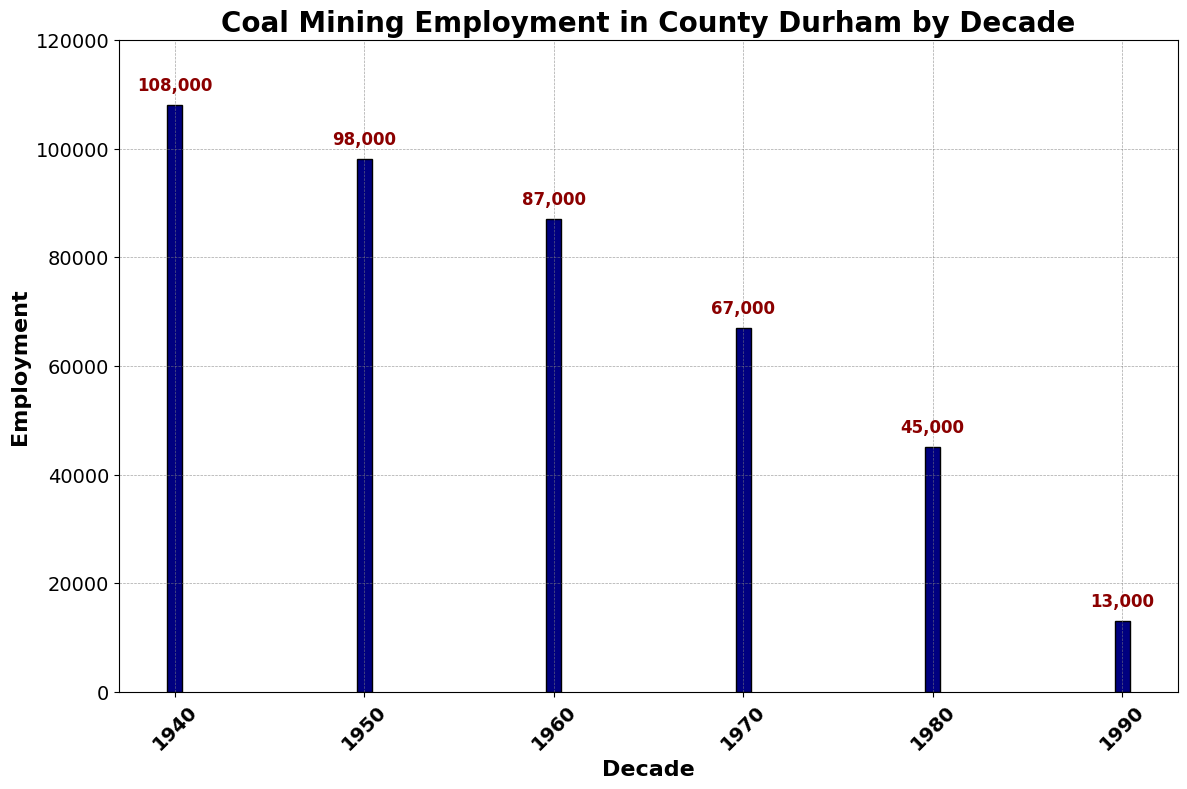What decade had the highest employment in coal mining? The figure shows bar heights representing employment values for each decade. The bar labeled "1940" is the tallest, indicating the highest employment.
Answer: 1940 Compare the employment between the 1960s and 1990s. Which decade had higher employment? The height of the bar for the 1960s is significantly taller than the bar for the 1990s, indicating higher employment in the 1960s.
Answer: 1960s What is the employment difference between the 1950s and 1980s? The bar for the 1950s shows 98,000 and the bar for the 1980s shows 45,000. The difference is 98,000 - 45,000.
Answer: 53,000 Which decade saw the greatest decline in coal mining employment compared to the previous decade? By comparing the heights of consecutive bars, the sharpest decline is between the 1980s (45,000) and the 1990s (13,000).
Answer: 1980s to 1990s What was the total employment in coal mining across all decades shown? Summing the values atop each bar: 108,000 + 98,000 + 87,000 + 67,000 + 45,000 + 13,000 = 418,000.
Answer: 418,000 Describe the general trend of coal mining employment from the 1940s to the 1990s. Visually, the bar heights decrease consistently from left (1940s) to right (1990s), indicating a general downward trend.
Answer: Downward trend What is the average employment across the decades? The total employment from all decades is 418,000. There are 6 decades. Average = 418,000 / 6.
Answer: 69,667 Is the employment in the 1970s closer to the employment of the 1960s or 1980s? Employment in the 1970s: 67,000, 1960s: 87,000, 1980s: 45,000. Calculate the absolute differences:
Answer: Closer to 1980s 